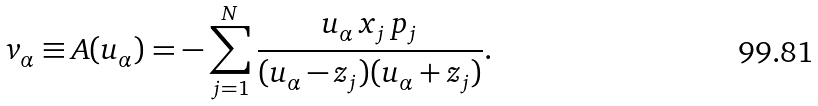<formula> <loc_0><loc_0><loc_500><loc_500>v _ { \alpha } \equiv A ( u _ { \alpha } ) = - \sum _ { j = 1 } ^ { N } \frac { u _ { \alpha } \, x _ { j } \, p _ { j } } { ( u _ { \alpha } - z _ { j } ) ( u _ { \alpha } + z _ { j } ) } .</formula> 